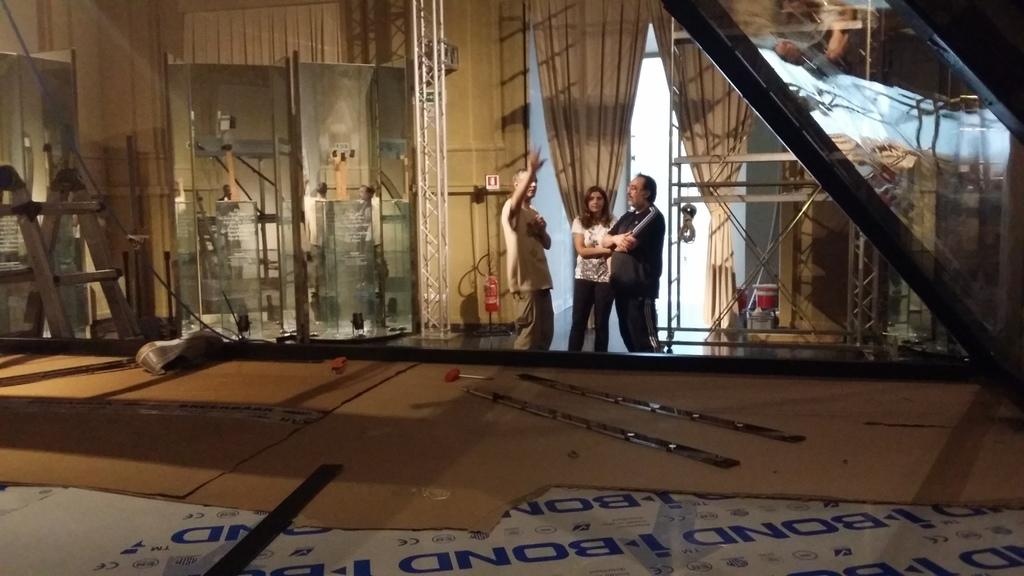How many people are in the image? There are three people standing in the image. What is the surface on which the people are standing? The people are standing on the floor. What is one object related to safety that can be seen in the image? A fire extinguisher is present in the image. What type of window treatment is visible in the image? There are curtains in the image. What type of object is used for climbing in the image? There is a ladder in the image. What type of object is typically used for covering feet and is present in the image? There is a shoe in the image. What is the background of the image? There is a wall in the background of the image. What type of industry is depicted in the image? There is no industry depicted in the image; it features people, a ladder, a fire extinguisher, curtains, rods, a shoe, and a wall. How many ants can be seen crawling on the shoe in the image? There are no ants present in the image; it only features a shoe and other objects. 